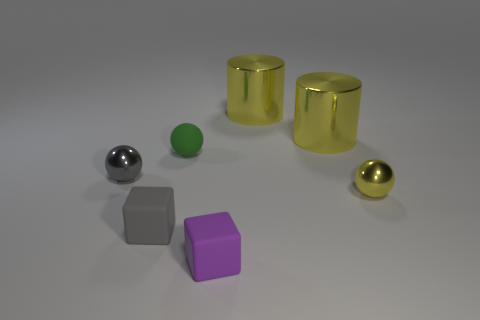Add 2 metal spheres. How many objects exist? 9 Subtract all spheres. How many objects are left? 4 Subtract all small purple blocks. Subtract all small purple cylinders. How many objects are left? 6 Add 3 things. How many things are left? 10 Add 1 tiny purple objects. How many tiny purple objects exist? 2 Subtract 0 gray cylinders. How many objects are left? 7 